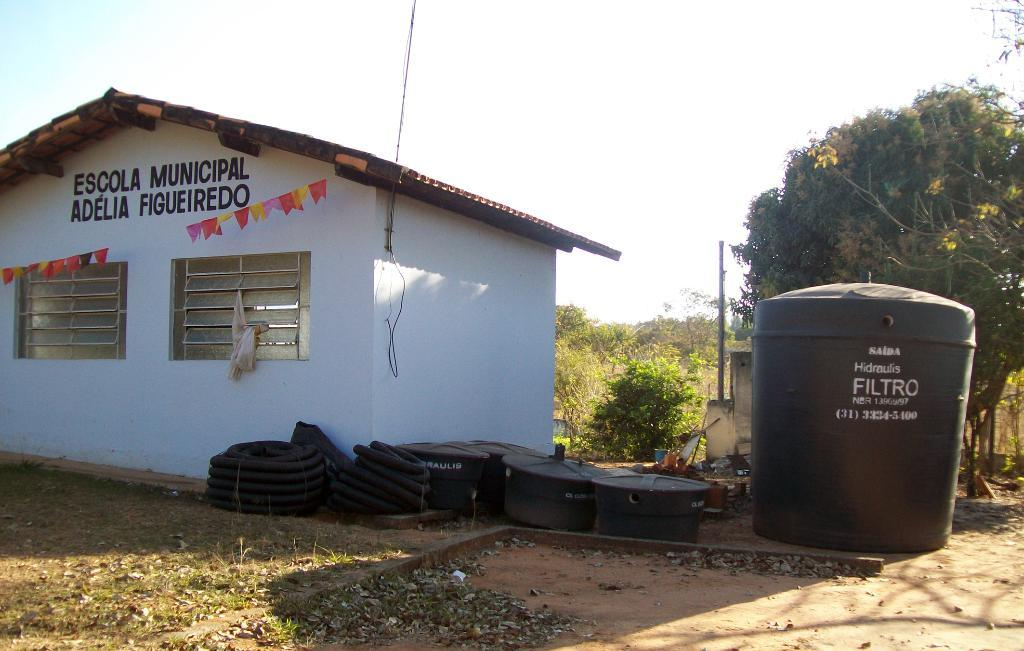What type of structure is visible in the image? There is a house in the image. What other large object can be seen in the image? There is a tank in the image. What type of natural elements are present in the image? There are trees in the image. What else can be found on the ground in the image? There are other objects on the ground in the image. What is visible in the background of the image? The sky is visible in the background of the image. Where is the jail located in the image? There is no jail present in the image. What type of home is shown in the image? The image features a house, which can be considered a type of home. Can you tell me how many shelves are visible in the image? There is no shelf present in the image. 